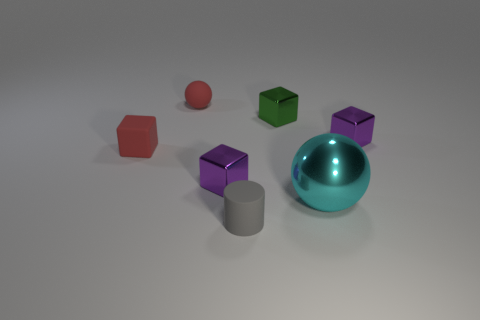Subtract 1 blocks. How many blocks are left? 3 Add 1 large metallic objects. How many objects exist? 8 Subtract all spheres. How many objects are left? 5 Add 3 tiny gray rubber things. How many tiny gray rubber things are left? 4 Add 2 green shiny cubes. How many green shiny cubes exist? 3 Subtract 0 red cylinders. How many objects are left? 7 Subtract all large yellow matte things. Subtract all large metallic balls. How many objects are left? 6 